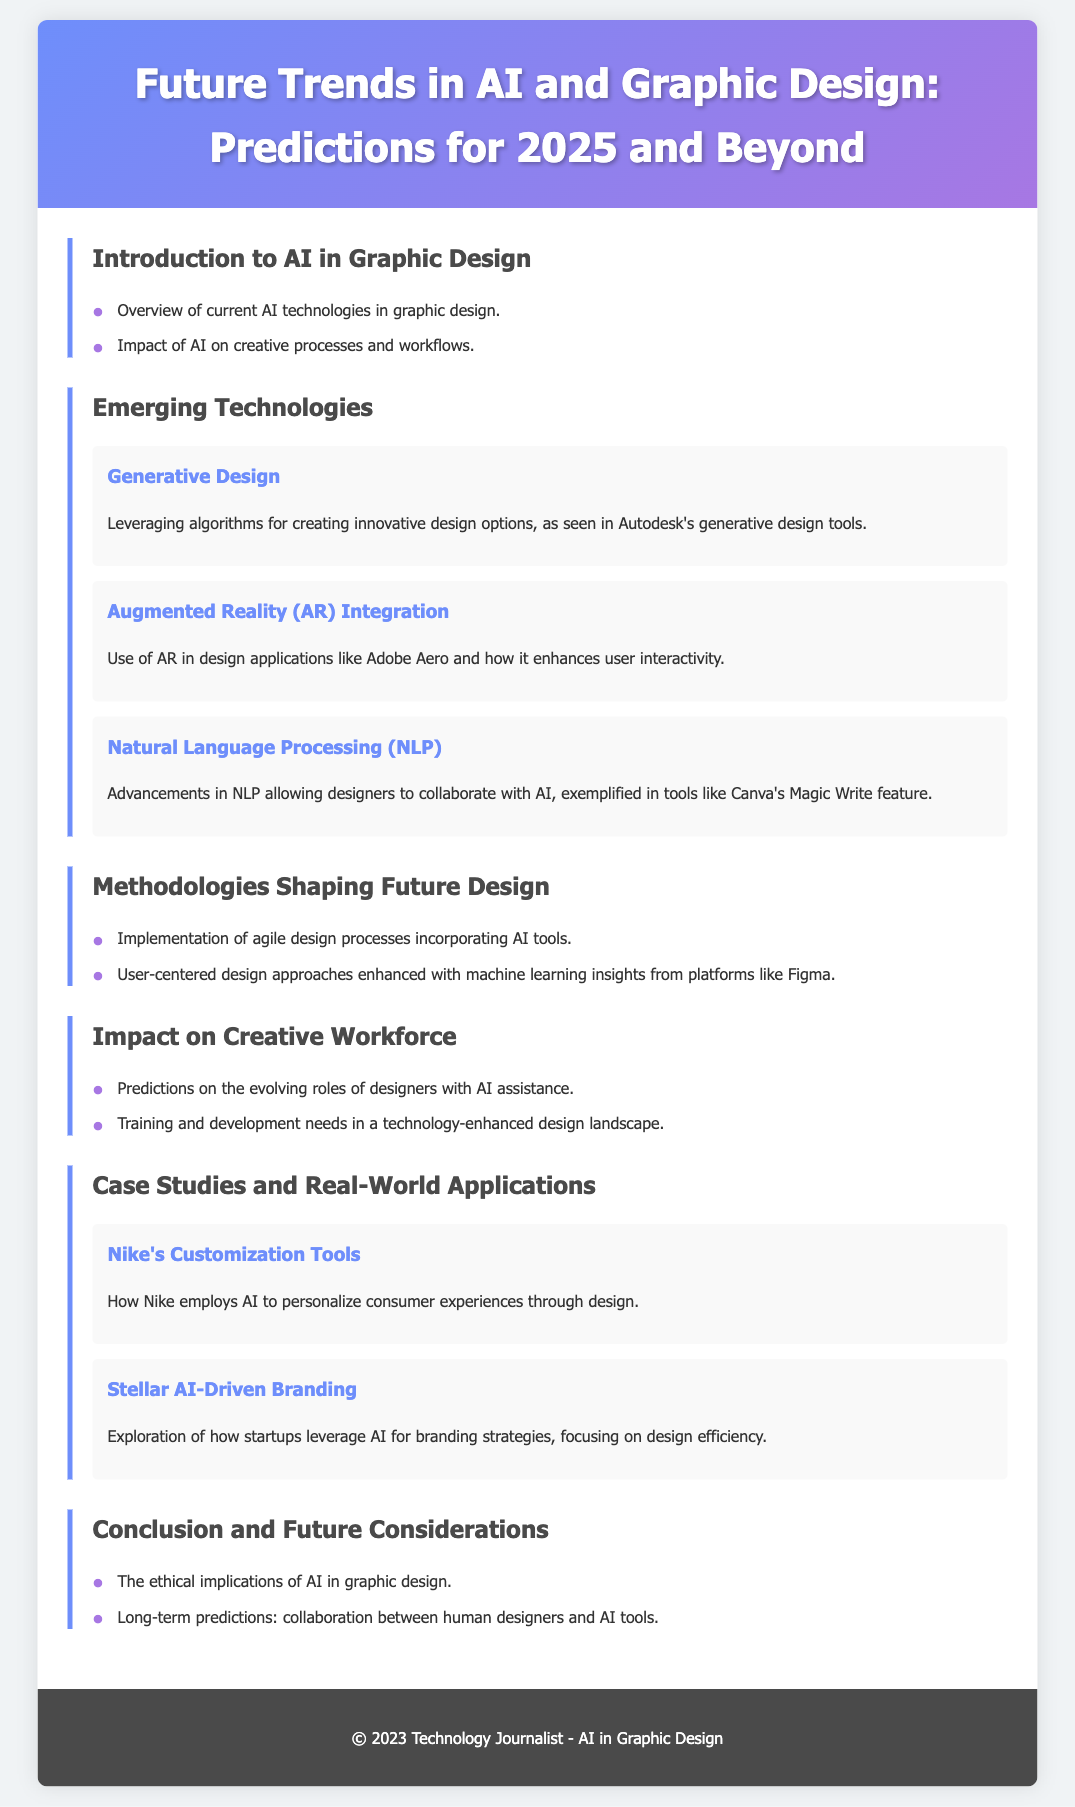What are two current AI technologies in graphic design? The document lists an overview of current AI technologies, including the impact of AI on creative processes.
Answer: AI technologies What is one example of Generative Design? The section on Emerging Technologies describes Autodesk's generative design tools as an example.
Answer: Autodesk's generative design tools Which tool features Natural Language Processing in graphic design? Canva's Magic Write feature is provided as an example of NLP advancements that allow designers to collaborate with AI.
Answer: Canva's Magic Write What methodology incorporates AI tools in design processes? The document mentions the implementation of agile design processes incorporating AI tools.
Answer: Agile design processes How does Nike use AI in their tools? Nike employs AI to personalize consumer experiences through design, as discussed in the case studies section.
Answer: Personalize consumer experiences What is a predicted change in the roles of designers due to AI assistance? The document discusses predictions on the evolving roles of designers with AI assistance.
Answer: Evolving roles What are two considerations mentioned in the conclusion regarding AI in graphic design? The conclusion touches on the ethical implications of AI and long-term predictions of collaboration between human designers and AI tools.
Answer: Ethical implications and collaboration What enhances user-centered design approaches according to the document? The user-centered design approaches are enhanced with machine learning insights from platforms like Figma.
Answer: Machine learning insights What type of application is Adobe Aero classified under? Adobe Aero is classified under Augmented Reality integration in design applications.
Answer: Augmented Reality integration 